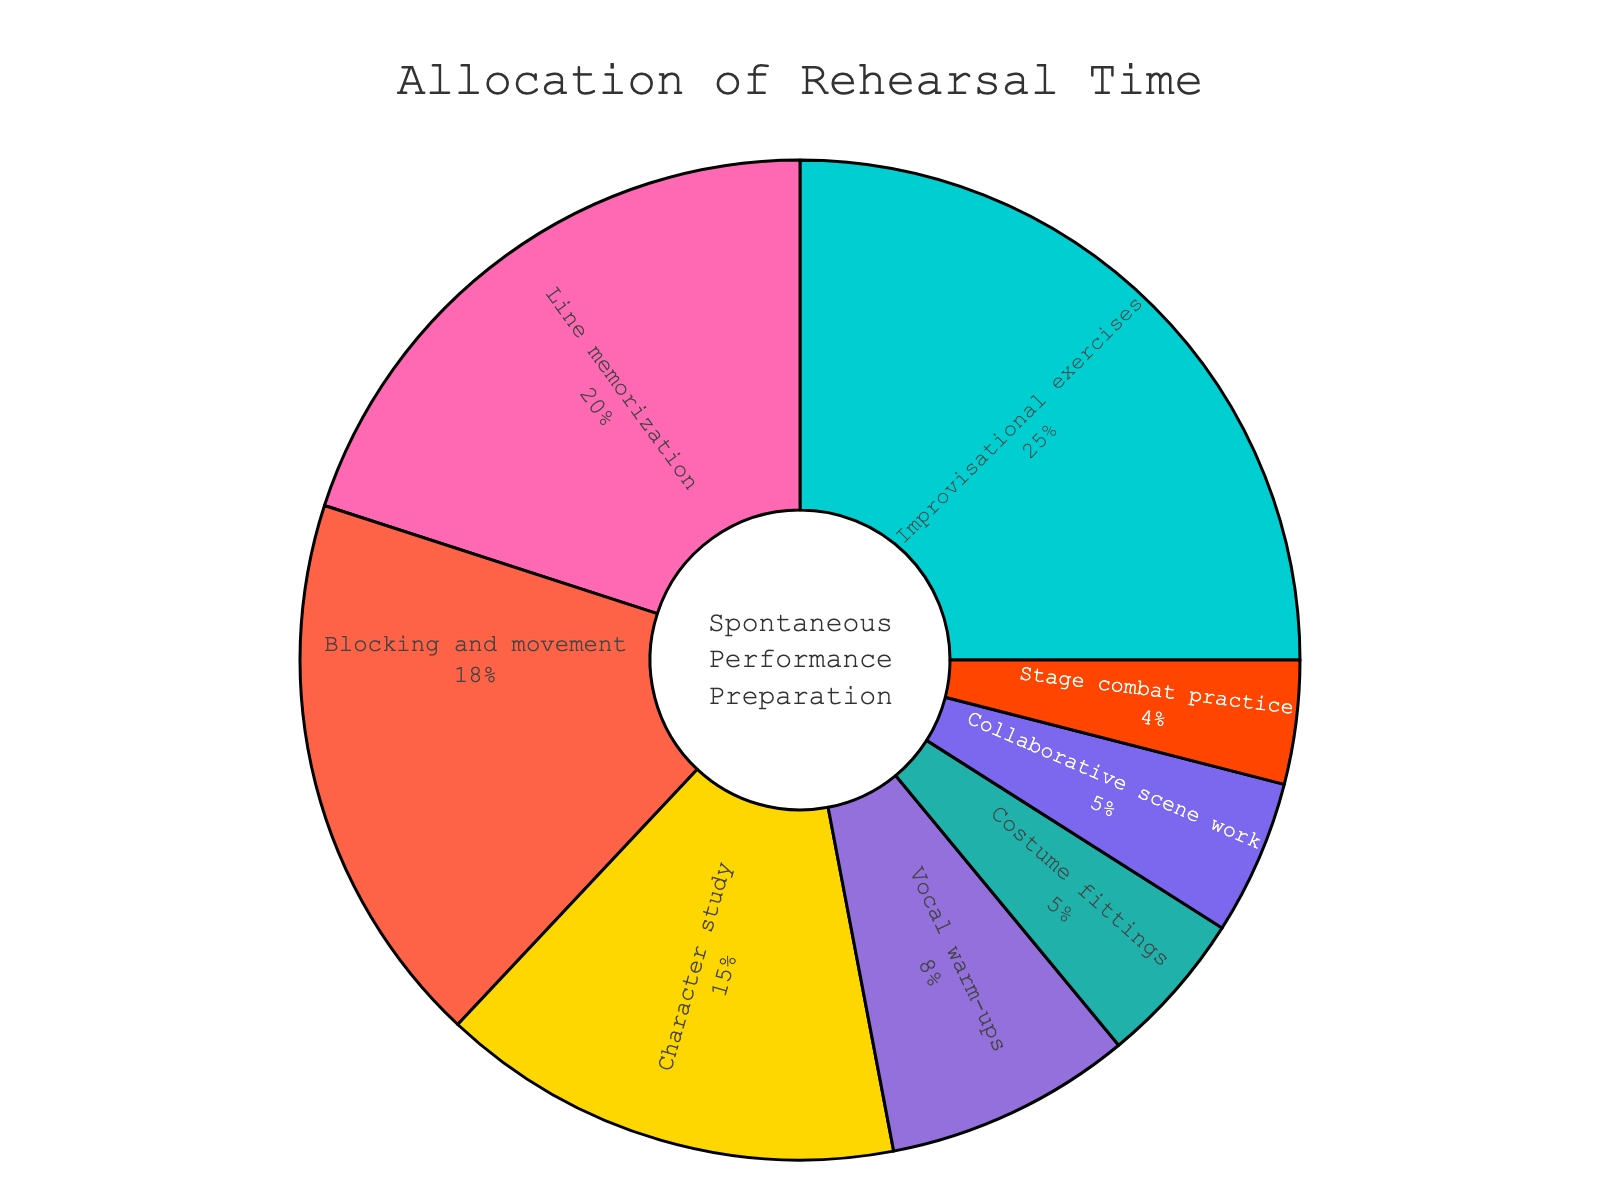what aspect receives the most rehearsal time? By examining the pie chart, observe which slice is the largest, indicating the highest percentage value.
Answer: Improvisational exercises How much more rehearsal time is allocated to Blocking and Movement compared to Costume Fittings? Find the percentage for Blocking and Movement (18%) and Costume Fittings (5%), then calculate the difference. 18% - 5% = 13%
Answer: 13% Which aspect receives the least rehearsal time? Look for the smallest slice in the pie chart, indicating the lowest percentage value.
Answer: Stage combat practice What is the combined rehearsal time for Character Study and Collaborative Scene Work? Find the percentages for Character Study (15%) and Collaborative Scene Work (5%), then sum them up. 15% + 5% = 20%
Answer: 20% What percentage of rehearsal time is allocated to activities related to physical movement (Blocking and Movement, Stage Combat Practice)? Find the percentages for Blocking and Movement (18%) and Stage Combat Practice (4%), then sum them up. 18% + 4% = 22%
Answer: 22% Are Vocal Warm-ups allocated more or less rehearsal time than Costume Fittings? Find the percentages for Vocal Warm-ups (8%) and Costume Fittings (5%) and compare them. 8% > 5%, so Vocal Warm-ups receive more time.
Answer: More What are the three aspects with the highest allocation of rehearsal time? Identify the three largest slices in the pie chart by looking for the highest percentages. They are Improvisational Exercises (25%), Line Memorization (20%), Blocking and Movement (18%).
Answer: Improvisational exercises, Line memorization, Blocking and movement How much combined time is allocated for Line Memorization, Character Study, and Vocal Warm-ups? Sum the percentages for Line Memorization (20%), Character Study (15%), and Vocal Warm-ups (8%). 20% + 15% + 8% = 43%
Answer: 43% What is the percentage difference between the highest and the lowest rehearsal time allocations? Find the highest percentage (Improvisational Exercises, 25%) and the lowest percentage (Stage Combat Practice, 4%), then calculate the difference. 25% - 4% = 21%
Answer: 21% What color represents Costume Fittings? Identify the slice labeled "Costume Fittings" and observe its color. Costume Fittings are represented by a greenish color.
Answer: Greenish 